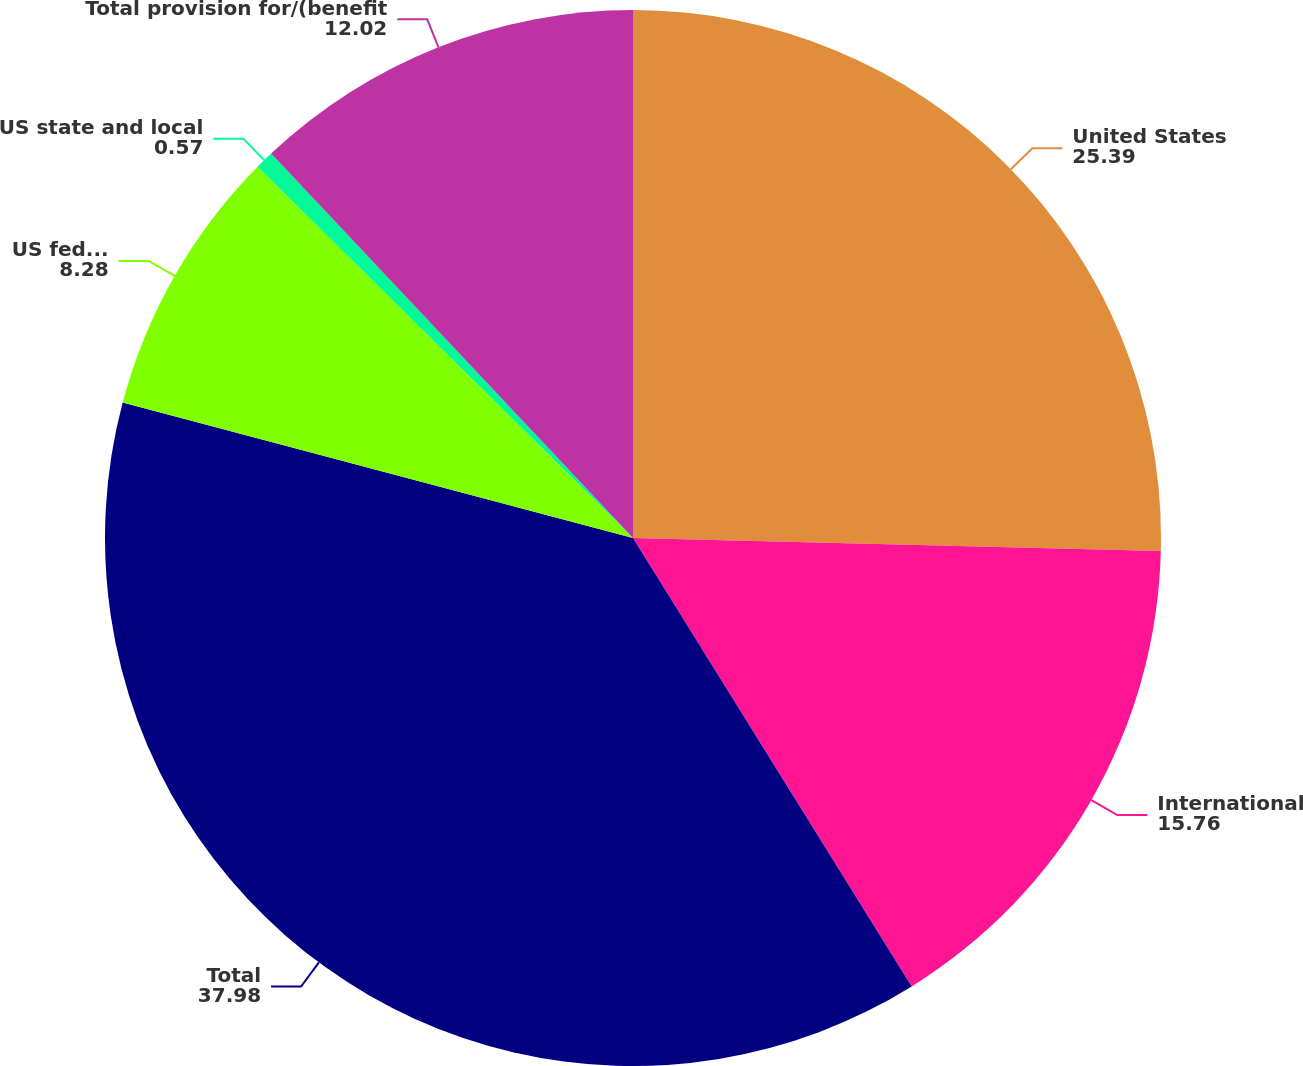Convert chart to OTSL. <chart><loc_0><loc_0><loc_500><loc_500><pie_chart><fcel>United States<fcel>International<fcel>Total<fcel>US federal<fcel>US state and local<fcel>Total provision for/(benefit<nl><fcel>25.39%<fcel>15.76%<fcel>37.98%<fcel>8.28%<fcel>0.57%<fcel>12.02%<nl></chart> 